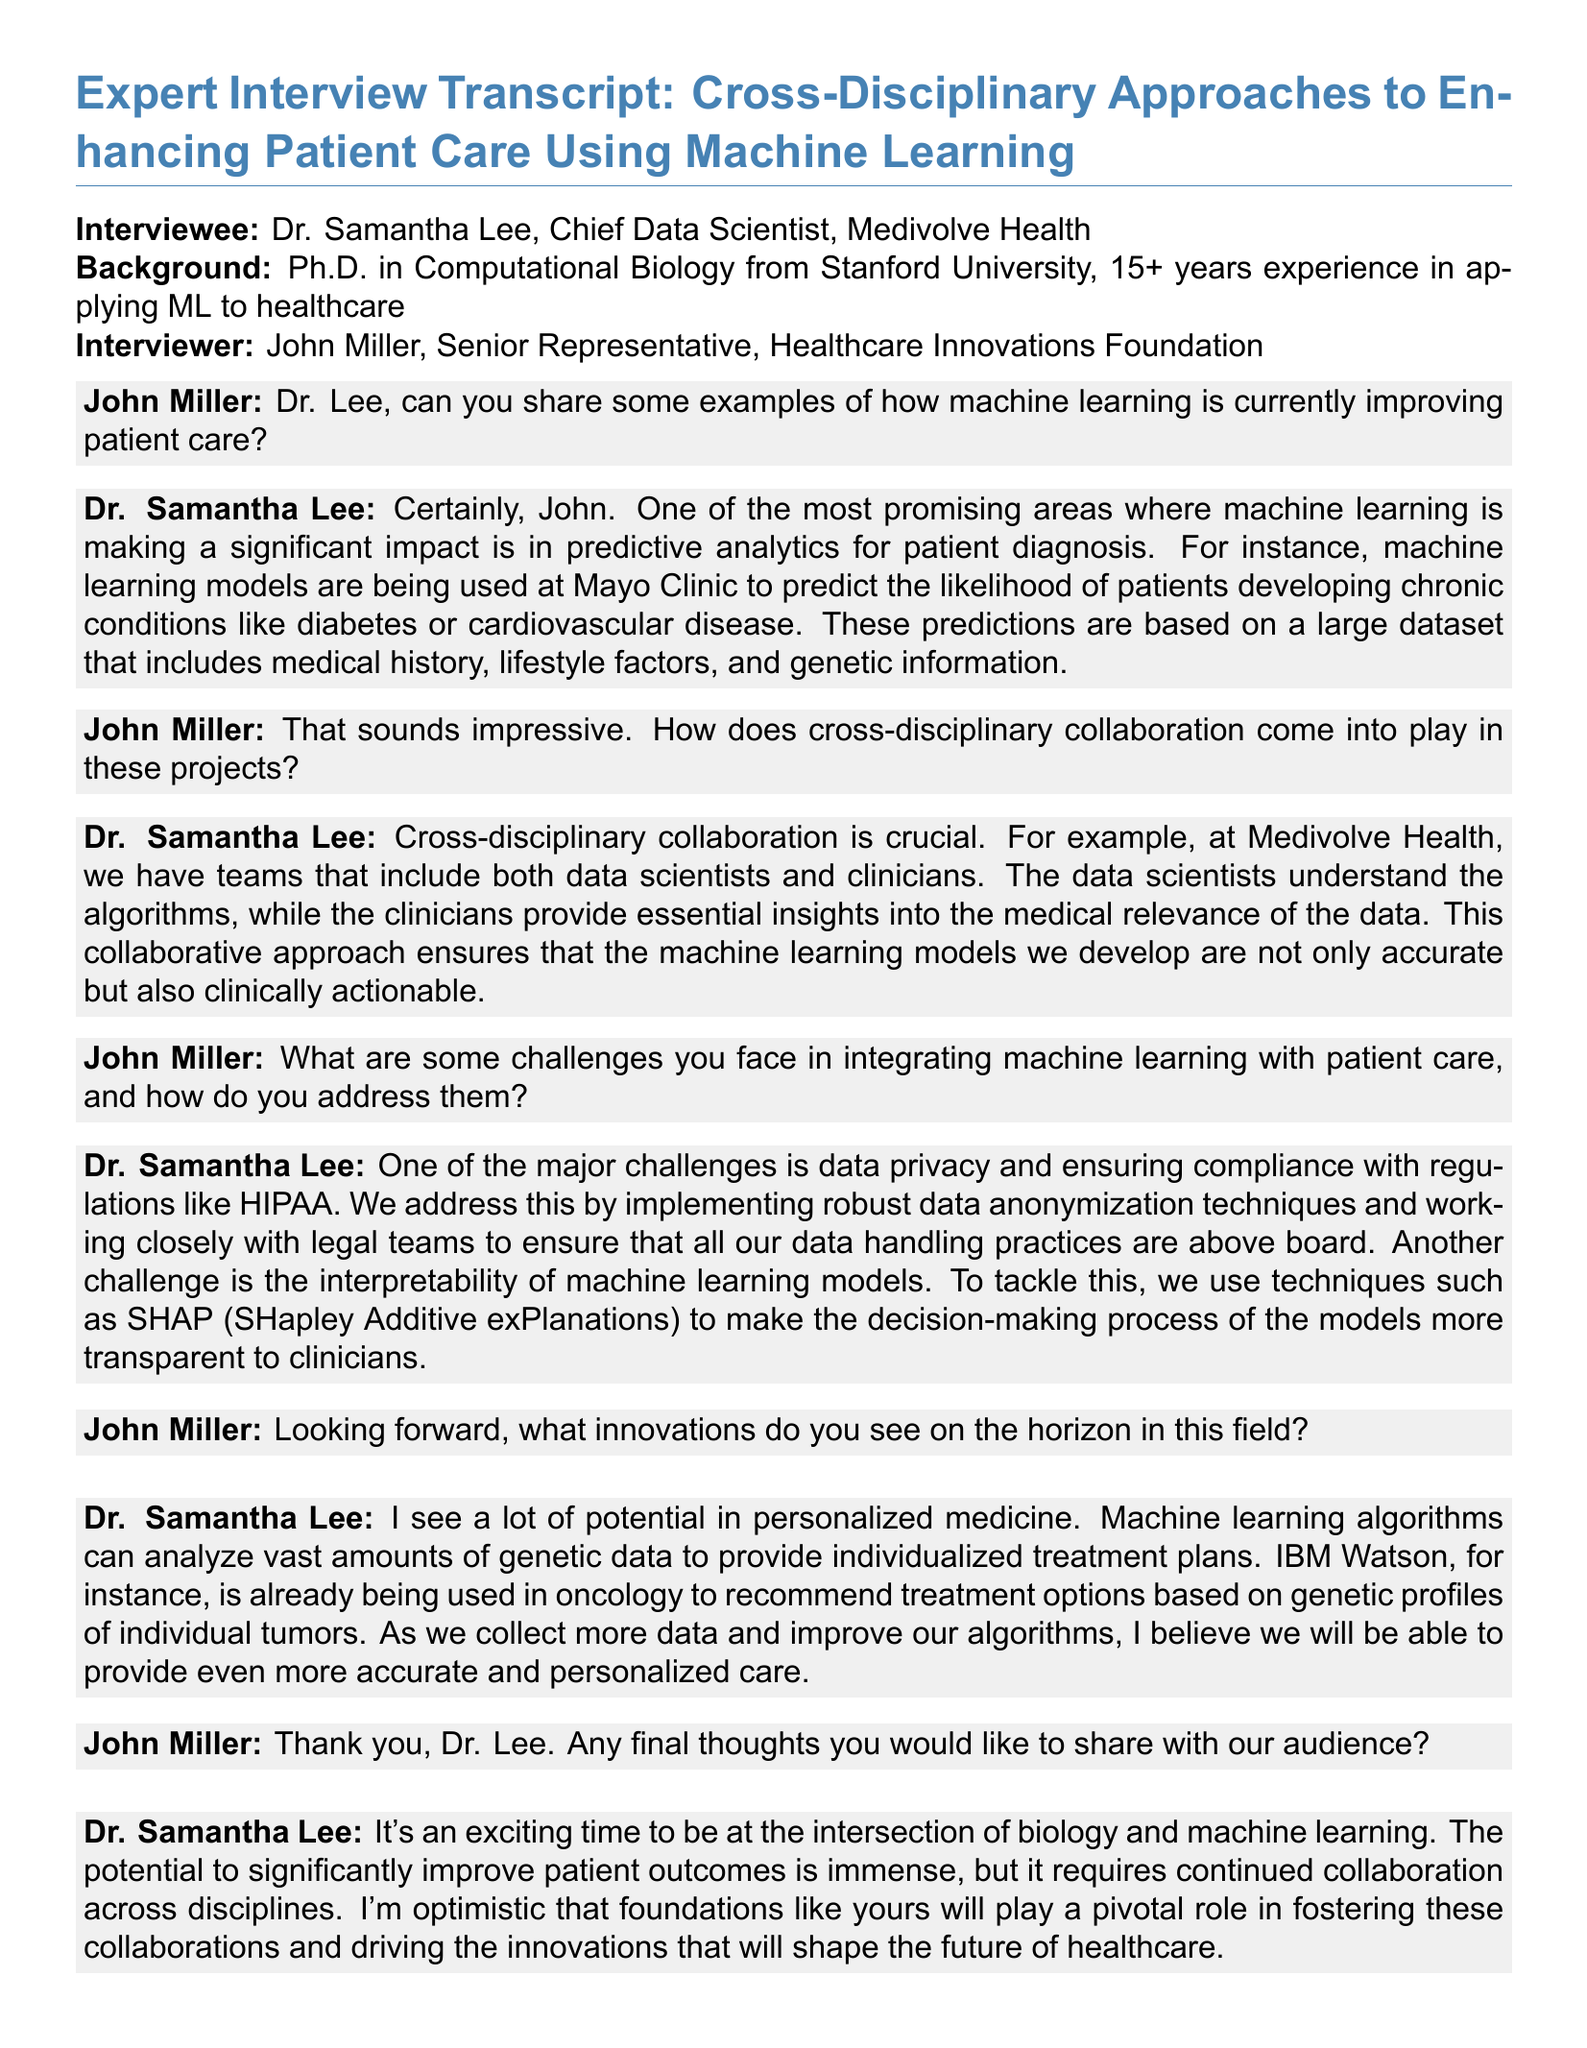What is Dr. Samantha Lee's title? The document states that Dr. Samantha Lee is the Chief Data Scientist at Medivolve Health.
Answer: Chief Data Scientist How many years of experience does Dr. Lee have in applying machine learning to healthcare? The interview mentions she has over 15 years of experience in the field.
Answer: 15+ What technique does Dr. Lee mention for making ML models interpretable? Dr. Lee refers to SHAP (SHapley Additive exPlanations) as a technique for interpretability.
Answer: SHAP Which healthcare institution is mentioned as using predictive analytics for diagnosing chronic conditions? The document specifically mentions Mayo Clinic regarding predictive analytics.
Answer: Mayo Clinic What potential innovation in healthcare does Dr. Lee see as promising? Dr. Lee discusses personalized medicine as a significant innovation on the horizon.
Answer: Personalized medicine What is one major challenge in integrating machine learning with patient care according to Dr. Lee? Dr. Lee highlights data privacy as one of the major challenges faced.
Answer: Data privacy What role do clinicians play in machine learning projects at Medivolve Health? Clinicians provide essential insights into the medical relevance of the data in these projects.
Answer: Essential insights How does Dr. Lee believe healthcare foundations can contribute to future innovations? She believes healthcare foundations will play a pivotal role in fostering collaborations.
Answer: Pivotal role 